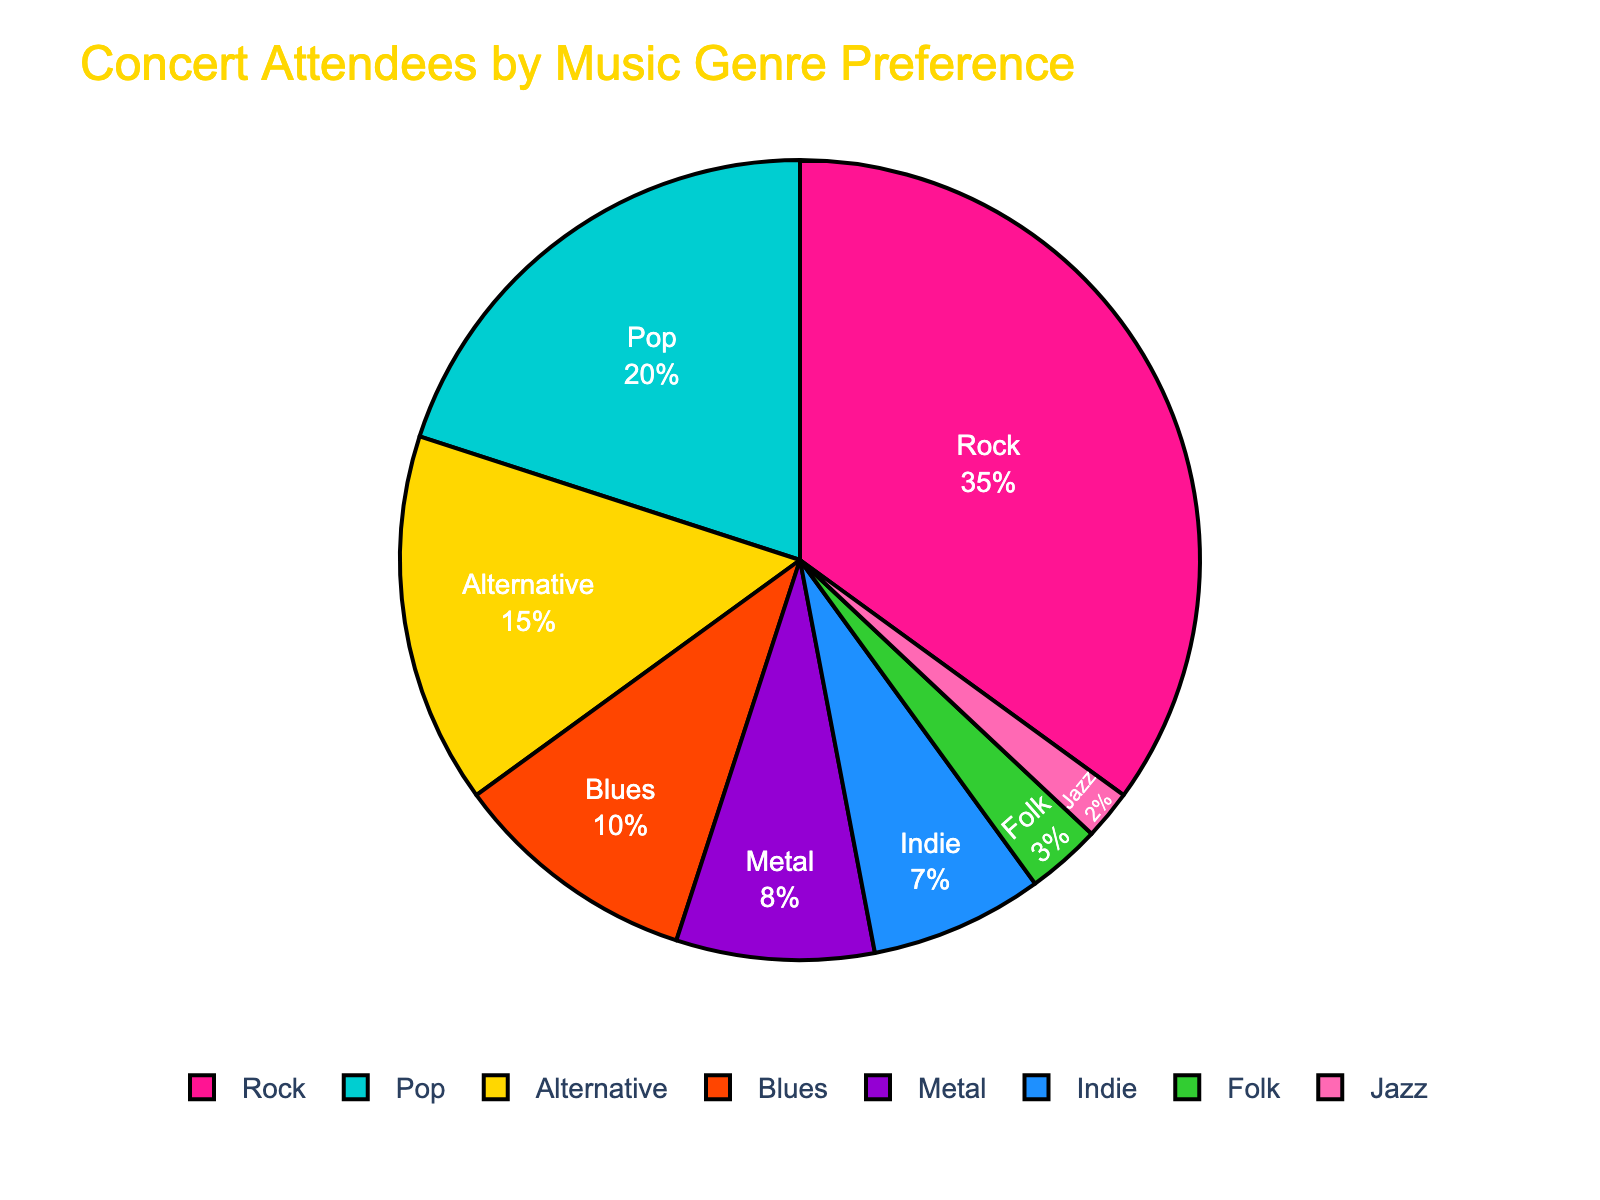What's the most popular music genre among concert attendees? According to the pie chart, the genre with the highest percentage is Rock, which holds 35% of the total concert attendees.
Answer: Rock How many genres have less than 10% preference among concert attendees? By referring to the pie chart, genres with less than 10% are Metal (8%), Indie (7%), Folk (3%), and Jazz (2%). There are four genres in total.
Answer: 4 What is the difference in percentage between the most and least popular genres? The most popular genre is Rock with 35%, and the least popular is Jazz with 2%. The difference between them is 35% - 2% = 33%.
Answer: 33% Which genres together make up around half of the concert attendees? Adding up the percentages of Rock (35%) and Pop (20%) gives us 35% + 20% = 55%, which accounts for more than half. However, Rock alone accounts for a significant portion, and so Rock, Pop, and Alternative together would far exceed half.
Answer: Rock and Pop What is the combined percentage of all genres with a preference of exactly 10% or less? The genres with 10% or less are Blues (10%), Metal (8%), Indie (7%), Folk (3%), and Jazz (2%). Summing these up: 10% + 8% + 7% + 3% + 2% = 30%.
Answer: 30% Which genre is typically associated with soothing and soulful music, and what percentage does it represent? Jazz is typically associated with soothing and soulful music. According to the chart, it represents 2% of the concert attendees.
Answer: Jazz, 2% Is Pop music more popular than Indie, and by how much? The percentage for Pop music is 20%, whereas for Indie it is 7%. The difference between them is 20% - 7% = 13%.
Answer: Yes, by 13% What's the sum of the percentages for Rock and Alternative genres? The percentages for Rock and Alternative are 35% and 15%, respectively. Summing these: 35% + 15% = 50%.
Answer: 50% Which genre, represented by the color gold, and what percentage does it hold? The color gold in the chart represents the Pop genre, which holds a 20% preference among concert attendees.
Answer: Pop, 20% 